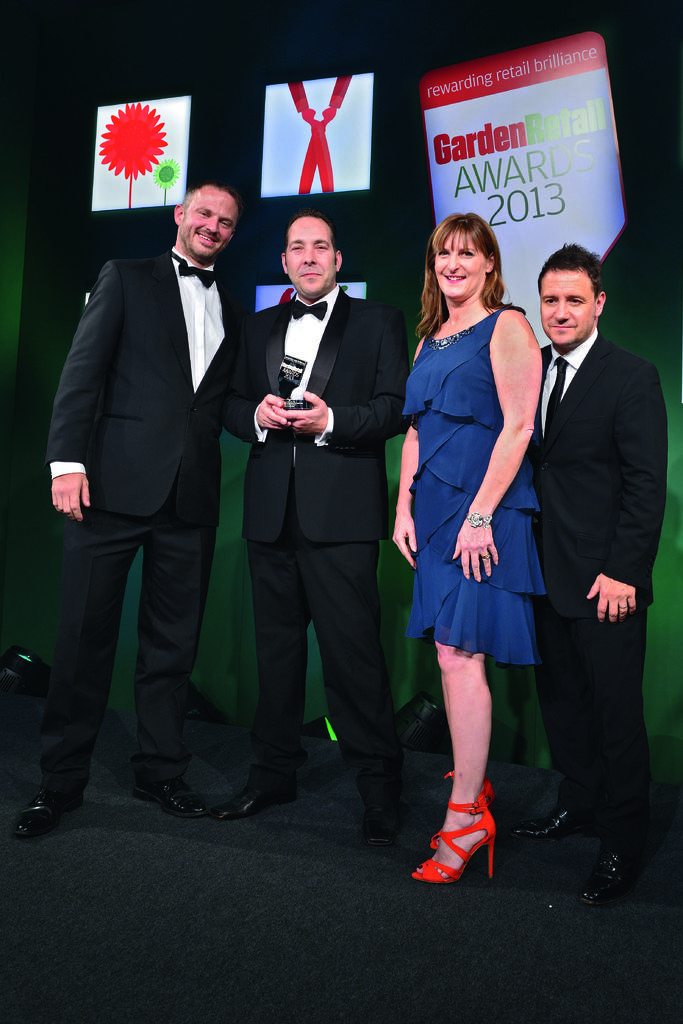How many people are the people are present in the image? There are four people in the image: three men and one woman. What are the people doing in the image? The people are standing on a platform and smiling. What can be seen in the background of the image? There are banners in the background of the image. What type of crate is being used to play basketball in the image? There is no crate or basketball present in the image; the people are standing on a platform and smiling. 